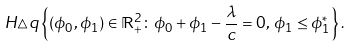Convert formula to latex. <formula><loc_0><loc_0><loc_500><loc_500>H \triangle q \left \{ ( \phi _ { 0 } , \phi _ { 1 } ) \in \mathbb { R } _ { + } ^ { 2 } \colon \phi _ { 0 } + \phi _ { 1 } - \frac { \lambda } { c } = 0 , \, \phi _ { 1 } \leq \phi ^ { * } _ { 1 } \right \} .</formula> 